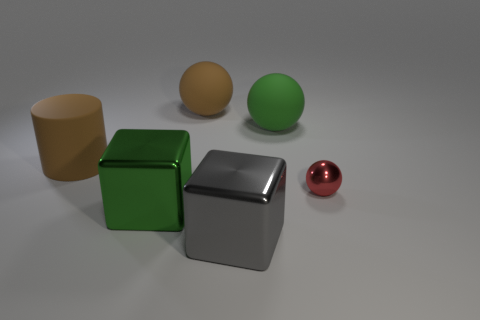There is another large object that is the same shape as the large gray metal object; what is it made of?
Your response must be concise. Metal. What shape is the object that is to the right of the big brown matte ball and in front of the red metallic ball?
Provide a succinct answer. Cube. What shape is the big green thing that is made of the same material as the brown sphere?
Offer a terse response. Sphere. What is the material of the big green thing that is to the right of the big green metallic block?
Keep it short and to the point. Rubber. Do the green thing behind the red shiny ball and the metallic thing that is on the left side of the gray block have the same size?
Your answer should be compact. Yes. The small metallic ball has what color?
Your answer should be compact. Red. There is a brown thing that is right of the large cylinder; is it the same shape as the gray thing?
Keep it short and to the point. No. What is the tiny thing made of?
Provide a succinct answer. Metal. There is a gray shiny thing that is the same size as the green block; what is its shape?
Your answer should be very brief. Cube. Is there a big shiny object of the same color as the tiny object?
Provide a succinct answer. No. 